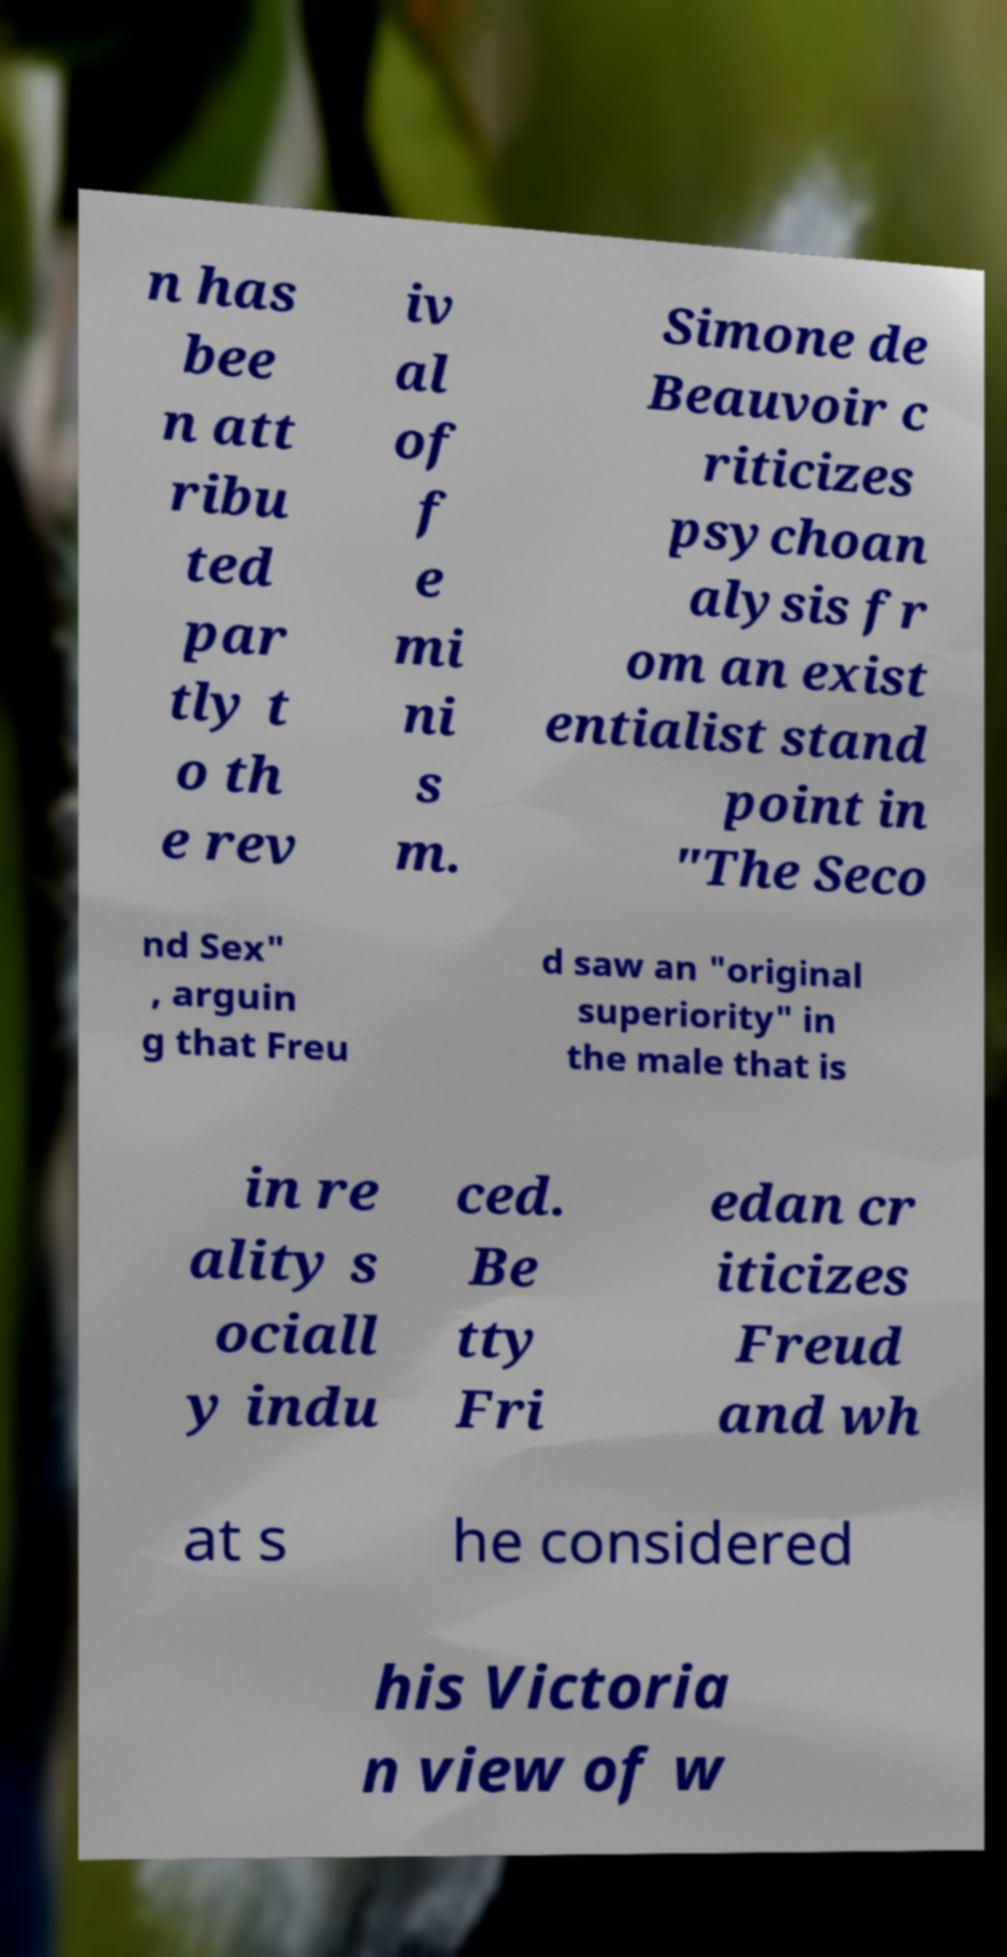What messages or text are displayed in this image? I need them in a readable, typed format. n has bee n att ribu ted par tly t o th e rev iv al of f e mi ni s m. Simone de Beauvoir c riticizes psychoan alysis fr om an exist entialist stand point in "The Seco nd Sex" , arguin g that Freu d saw an "original superiority" in the male that is in re ality s ociall y indu ced. Be tty Fri edan cr iticizes Freud and wh at s he considered his Victoria n view of w 